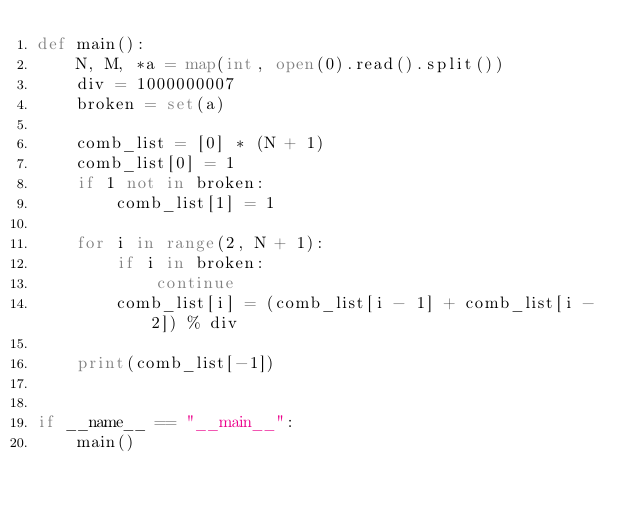<code> <loc_0><loc_0><loc_500><loc_500><_Python_>def main():
    N, M, *a = map(int, open(0).read().split())
    div = 1000000007
    broken = set(a)
 
    comb_list = [0] * (N + 1)
    comb_list[0] = 1
    if 1 not in broken:
        comb_list[1] = 1
 
    for i in range(2, N + 1):
        if i in broken:
            continue
        comb_list[i] = (comb_list[i - 1] + comb_list[i - 2]) % div
 
    print(comb_list[-1])
 
 
if __name__ == "__main__":
    main()</code> 